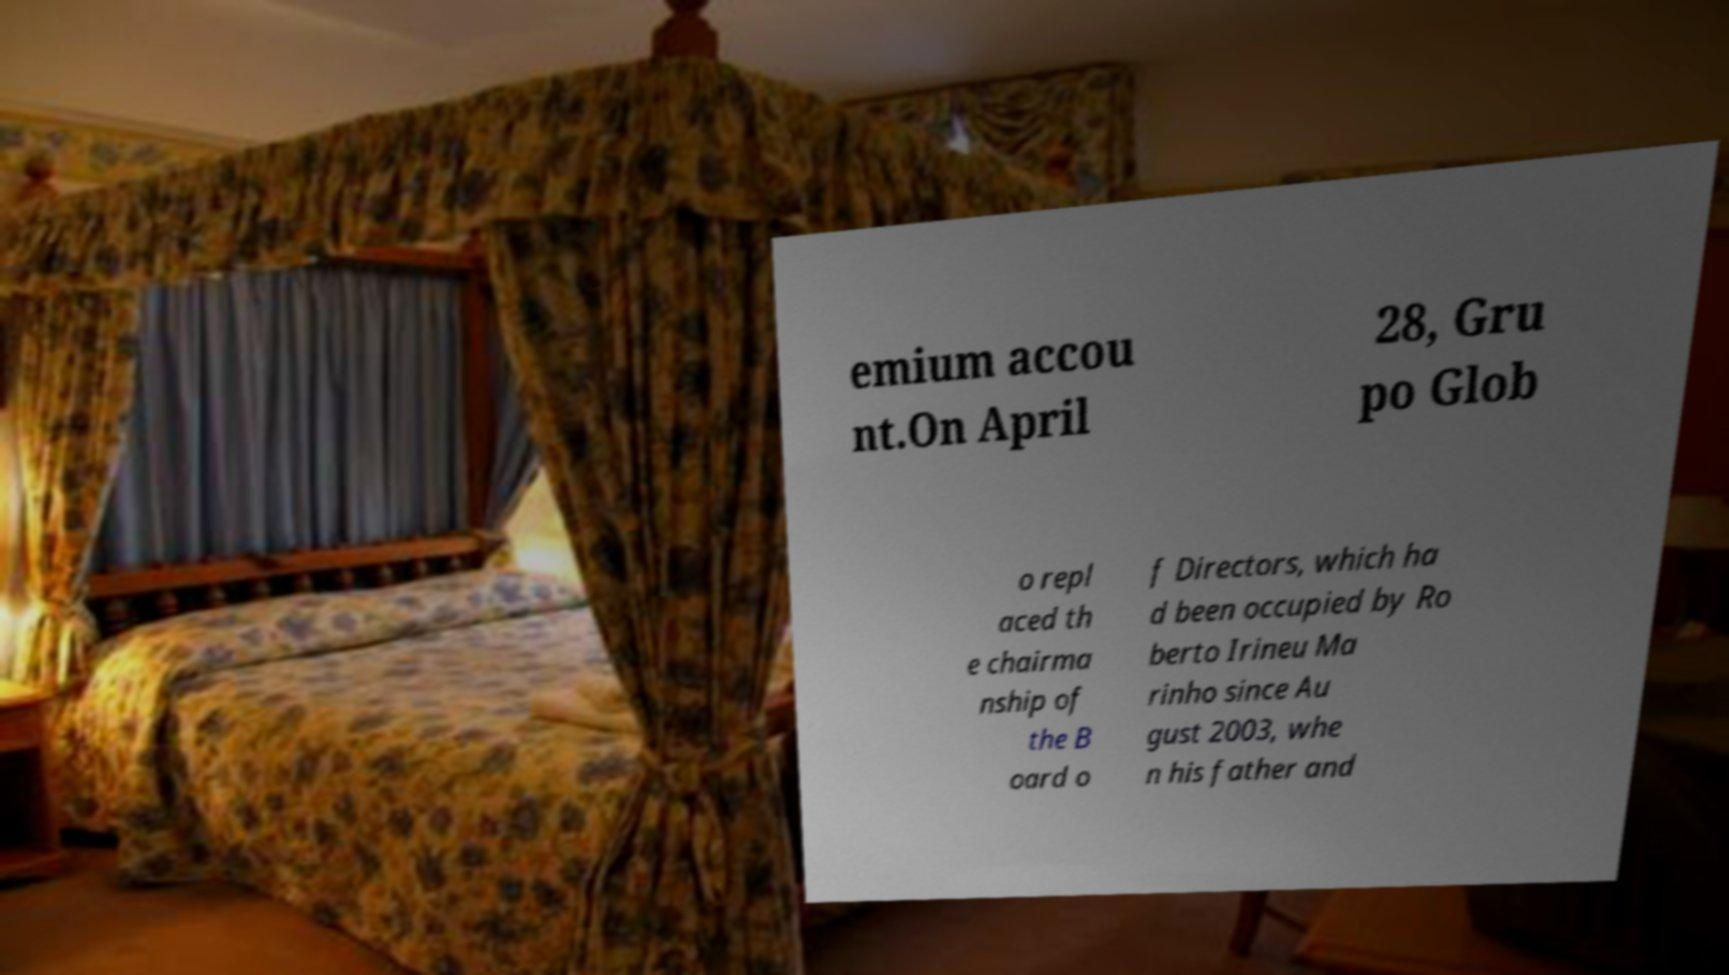Please identify and transcribe the text found in this image. emium accou nt.On April 28, Gru po Glob o repl aced th e chairma nship of the B oard o f Directors, which ha d been occupied by Ro berto Irineu Ma rinho since Au gust 2003, whe n his father and 